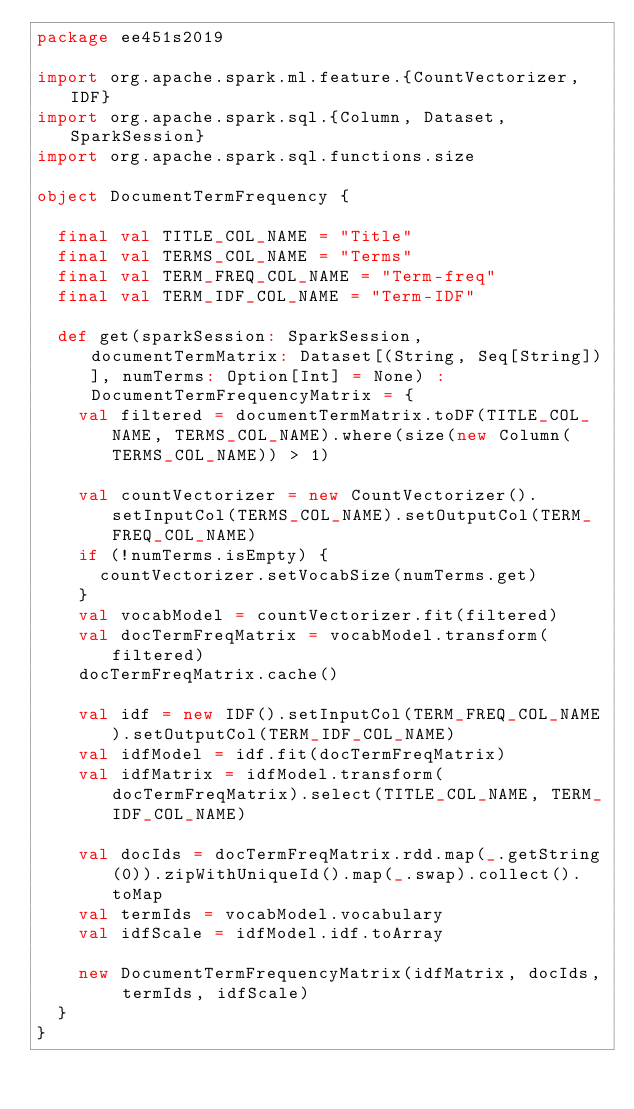<code> <loc_0><loc_0><loc_500><loc_500><_Scala_>package ee451s2019

import org.apache.spark.ml.feature.{CountVectorizer, IDF}
import org.apache.spark.sql.{Column, Dataset, SparkSession}
import org.apache.spark.sql.functions.size

object DocumentTermFrequency {

	final val TITLE_COL_NAME = "Title"
	final val TERMS_COL_NAME = "Terms"
	final val TERM_FREQ_COL_NAME = "Term-freq"
	final val TERM_IDF_COL_NAME = "Term-IDF"

	def get(sparkSession: SparkSession, documentTermMatrix: Dataset[(String, Seq[String])], numTerms: Option[Int] = None) : DocumentTermFrequencyMatrix = {
		val filtered = documentTermMatrix.toDF(TITLE_COL_NAME, TERMS_COL_NAME).where(size(new Column(TERMS_COL_NAME)) > 1)

		val countVectorizer = new CountVectorizer().setInputCol(TERMS_COL_NAME).setOutputCol(TERM_FREQ_COL_NAME)
		if (!numTerms.isEmpty) {
			countVectorizer.setVocabSize(numTerms.get)
		}
		val vocabModel = countVectorizer.fit(filtered)
		val docTermFreqMatrix = vocabModel.transform(filtered)
		docTermFreqMatrix.cache()

		val idf = new IDF().setInputCol(TERM_FREQ_COL_NAME).setOutputCol(TERM_IDF_COL_NAME)
		val idfModel = idf.fit(docTermFreqMatrix)
		val idfMatrix = idfModel.transform(docTermFreqMatrix).select(TITLE_COL_NAME, TERM_IDF_COL_NAME)

		val docIds = docTermFreqMatrix.rdd.map(_.getString(0)).zipWithUniqueId().map(_.swap).collect().toMap
		val termIds = vocabModel.vocabulary
		val idfScale = idfModel.idf.toArray

		new DocumentTermFrequencyMatrix(idfMatrix, docIds, termIds, idfScale)
	}
}
</code> 